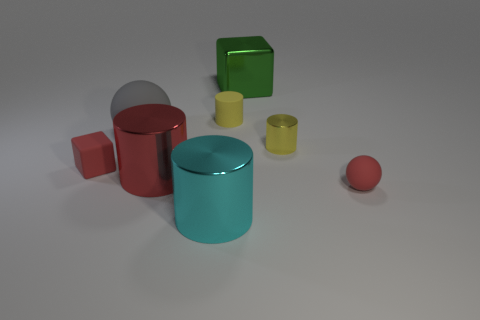Add 2 cyan metallic things. How many objects exist? 10 Subtract all balls. How many objects are left? 6 Subtract 0 purple balls. How many objects are left? 8 Subtract all big cyan metallic objects. Subtract all small red balls. How many objects are left? 6 Add 7 rubber spheres. How many rubber spheres are left? 9 Add 2 blue rubber spheres. How many blue rubber spheres exist? 2 